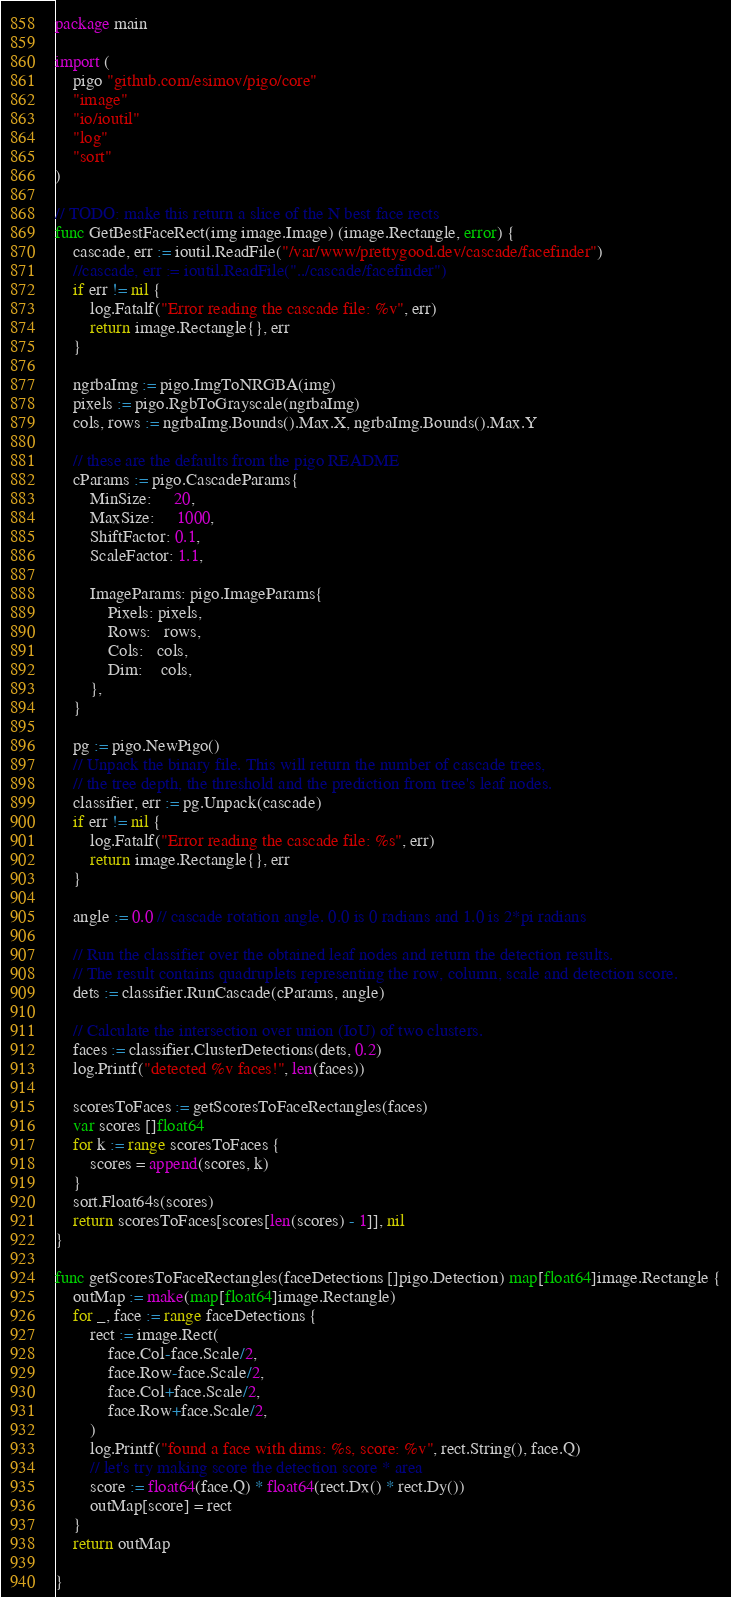Convert code to text. <code><loc_0><loc_0><loc_500><loc_500><_Go_>package main

import (
	pigo "github.com/esimov/pigo/core"
	"image"
	"io/ioutil"
	"log"
	"sort"
)

// TODO: make this return a slice of the N best face rects
func GetBestFaceRect(img image.Image) (image.Rectangle, error) {
	cascade, err := ioutil.ReadFile("/var/www/prettygood.dev/cascade/facefinder")
	//cascade, err := ioutil.ReadFile("../cascade/facefinder")
	if err != nil {
		log.Fatalf("Error reading the cascade file: %v", err)
		return image.Rectangle{}, err
	}

	ngrbaImg := pigo.ImgToNRGBA(img)
	pixels := pigo.RgbToGrayscale(ngrbaImg)
	cols, rows := ngrbaImg.Bounds().Max.X, ngrbaImg.Bounds().Max.Y

	// these are the defaults from the pigo README
	cParams := pigo.CascadeParams{
		MinSize:     20,
		MaxSize:     1000,
		ShiftFactor: 0.1,
		ScaleFactor: 1.1,

		ImageParams: pigo.ImageParams{
			Pixels: pixels,
			Rows:   rows,
			Cols:   cols,
			Dim:    cols,
		},
	}

	pg := pigo.NewPigo()
	// Unpack the binary file. This will return the number of cascade trees,
	// the tree depth, the threshold and the prediction from tree's leaf nodes.
	classifier, err := pg.Unpack(cascade)
	if err != nil {
		log.Fatalf("Error reading the cascade file: %s", err)
		return image.Rectangle{}, err
	}

	angle := 0.0 // cascade rotation angle. 0.0 is 0 radians and 1.0 is 2*pi radians

	// Run the classifier over the obtained leaf nodes and return the detection results.
	// The result contains quadruplets representing the row, column, scale and detection score.
	dets := classifier.RunCascade(cParams, angle)

	// Calculate the intersection over union (IoU) of two clusters.
	faces := classifier.ClusterDetections(dets, 0.2)
	log.Printf("detected %v faces!", len(faces))

	scoresToFaces := getScoresToFaceRectangles(faces)
	var scores []float64
	for k := range scoresToFaces {
		scores = append(scores, k)
	}
	sort.Float64s(scores)
	return scoresToFaces[scores[len(scores) - 1]], nil
}

func getScoresToFaceRectangles(faceDetections []pigo.Detection) map[float64]image.Rectangle {
	outMap := make(map[float64]image.Rectangle)
	for _, face := range faceDetections {
		rect := image.Rect(
			face.Col-face.Scale/2,
			face.Row-face.Scale/2,
			face.Col+face.Scale/2,
			face.Row+face.Scale/2,
		)
		log.Printf("found a face with dims: %s, score: %v", rect.String(), face.Q)
		// let's try making score the detection score * area
		score := float64(face.Q) * float64(rect.Dx() * rect.Dy())
		outMap[score] = rect
	}
	return outMap

}
</code> 